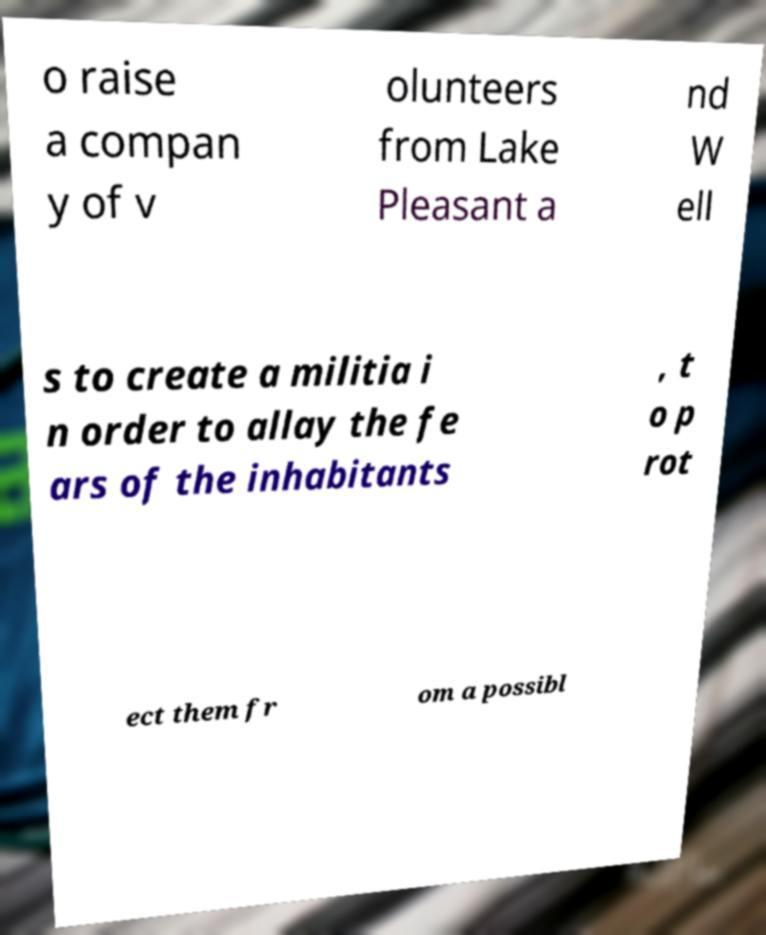Could you extract and type out the text from this image? o raise a compan y of v olunteers from Lake Pleasant a nd W ell s to create a militia i n order to allay the fe ars of the inhabitants , t o p rot ect them fr om a possibl 